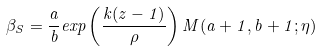<formula> <loc_0><loc_0><loc_500><loc_500>\beta _ { S } = \frac { a } { b } e x p \left ( \frac { k ( z - 1 ) } { \rho } \right ) M ( a + 1 , b + 1 ; \eta )</formula> 